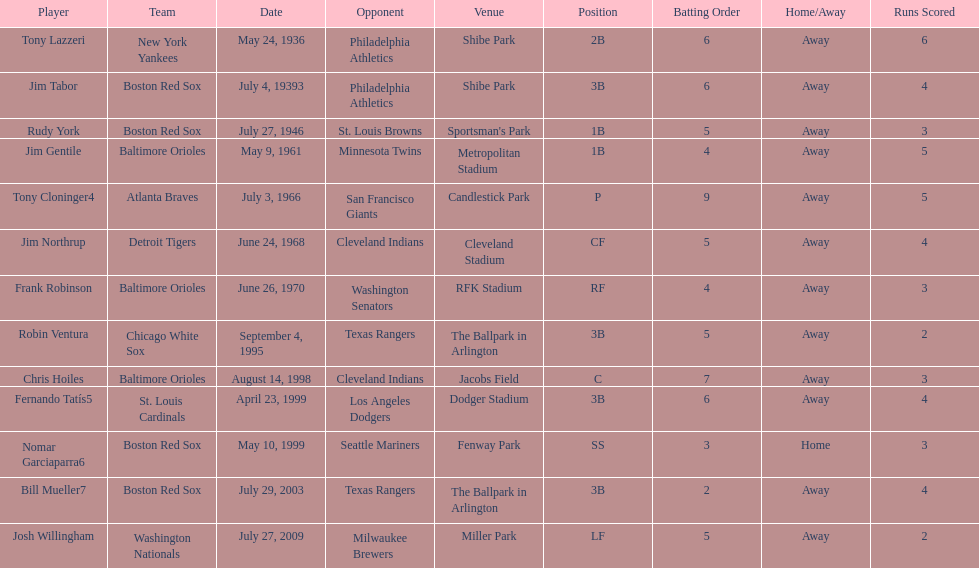What was the name of the player who accomplished this in 1999 but played for the boston red sox? Nomar Garciaparra. 